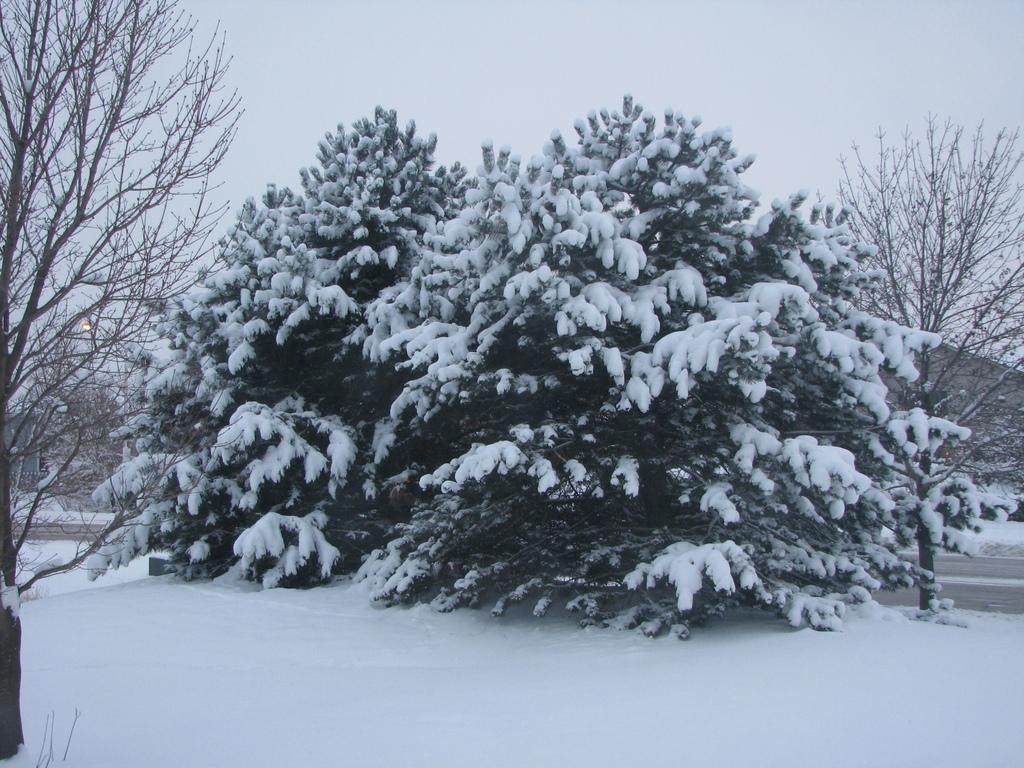What types of vegetation are present in the image? The image contains plants and trees. How are the plants and trees in the image affected by the weather? The plants and trees are covered with snow. Can you describe the ground in the image? There is snow at the bottom of the image. What part of the natural environment is visible in the image? The sky is visible at the top of the image. What is the price of the fog in the image? There is no fog present in the image, and therefore no price can be determined. 